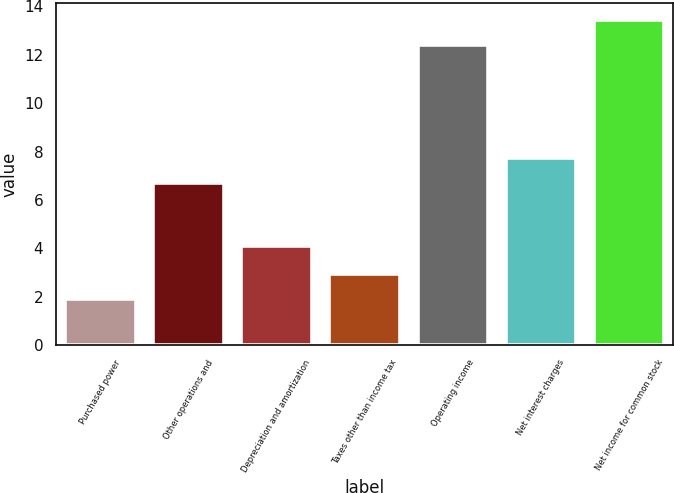<chart> <loc_0><loc_0><loc_500><loc_500><bar_chart><fcel>Purchased power<fcel>Other operations and<fcel>Depreciation and amortization<fcel>Taxes other than income tax<fcel>Operating income<fcel>Net interest charges<fcel>Net income for common stock<nl><fcel>1.9<fcel>6.7<fcel>4.1<fcel>2.95<fcel>12.4<fcel>7.75<fcel>13.45<nl></chart> 